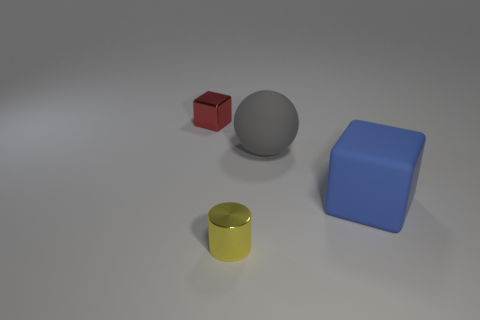Add 1 tiny purple metal cylinders. How many objects exist? 5 Subtract all balls. How many objects are left? 3 Add 1 gray rubber balls. How many gray rubber balls are left? 2 Add 4 gray rubber spheres. How many gray rubber spheres exist? 5 Subtract 0 cyan cylinders. How many objects are left? 4 Subtract all tiny yellow cylinders. Subtract all gray spheres. How many objects are left? 2 